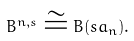Convert formula to latex. <formula><loc_0><loc_0><loc_500><loc_500>B ^ { n , s } \cong B ( s \L a _ { n } ) .</formula> 